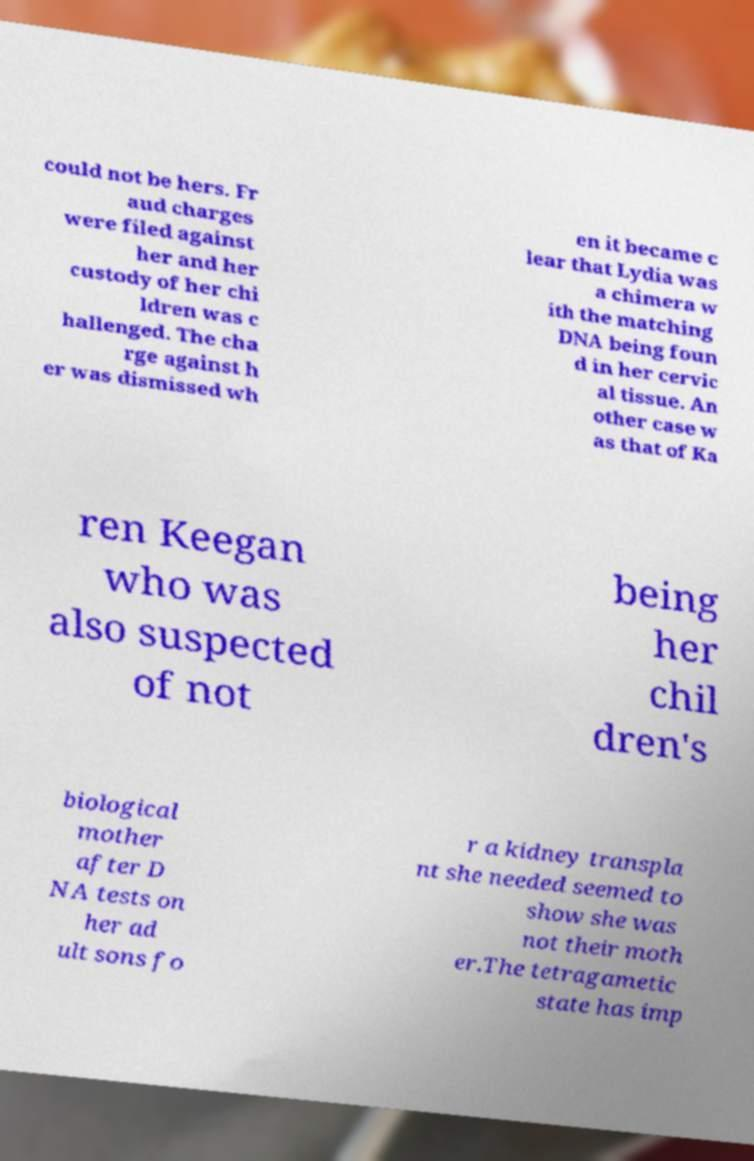Please read and relay the text visible in this image. What does it say? could not be hers. Fr aud charges were filed against her and her custody of her chi ldren was c hallenged. The cha rge against h er was dismissed wh en it became c lear that Lydia was a chimera w ith the matching DNA being foun d in her cervic al tissue. An other case w as that of Ka ren Keegan who was also suspected of not being her chil dren's biological mother after D NA tests on her ad ult sons fo r a kidney transpla nt she needed seemed to show she was not their moth er.The tetragametic state has imp 